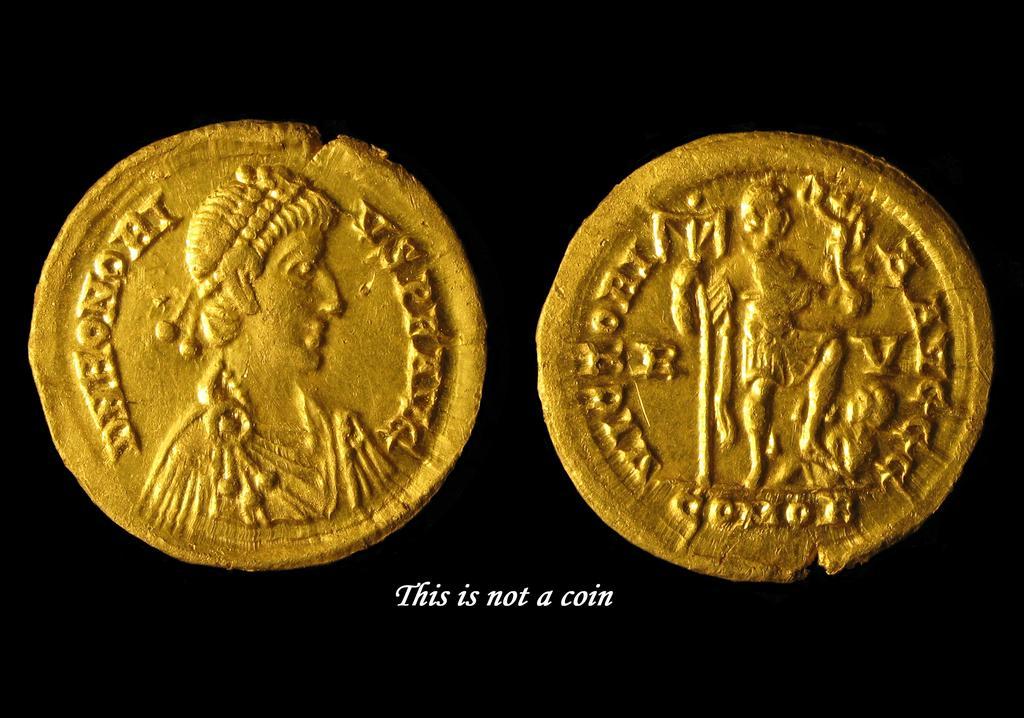Can you describe this image briefly? In this picture I can see there are two coins and there is some symbol on the coin and there is something written at the bottom of the image. The backdrop is dark. 